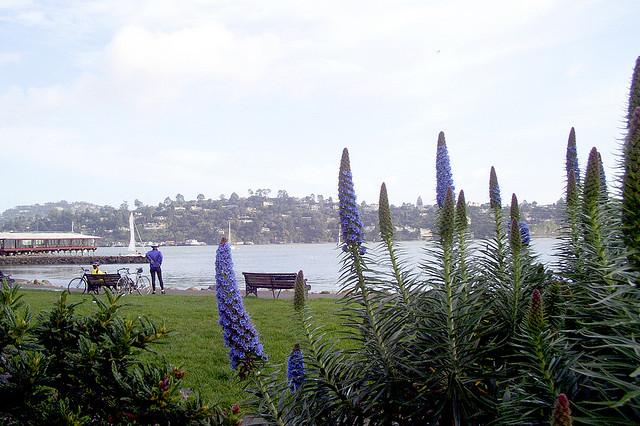What are the benches facing?
Answer briefly. Water. Are there bikes  shown?
Give a very brief answer. Yes. Are the flowers all the same color?
Write a very short answer. No. How many chairs are there?
Concise answer only. 2. 